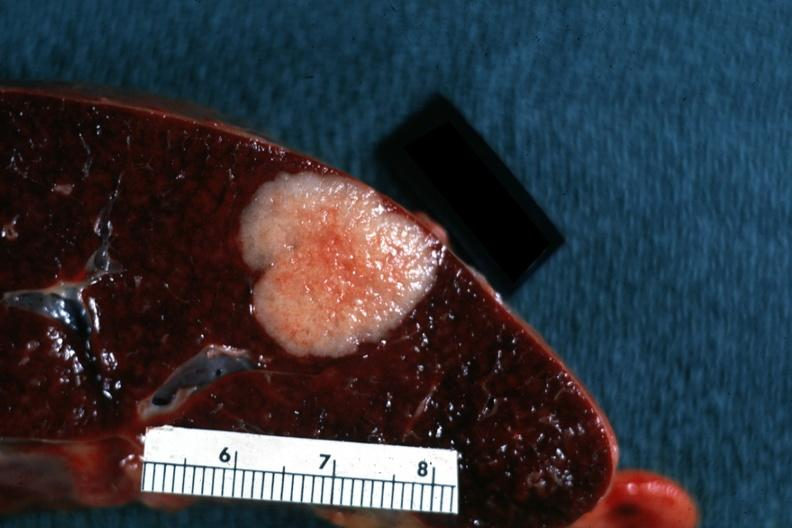s hematologic present?
Answer the question using a single word or phrase. Yes 